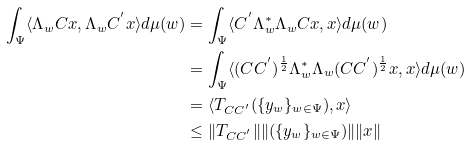<formula> <loc_0><loc_0><loc_500><loc_500>\int _ { \Psi } \langle \Lambda _ { w } C x , \Lambda _ { w } C ^ { ^ { \prime } } x \rangle d \mu ( w ) & = \int _ { \Psi } \langle C ^ { ^ { \prime } } \Lambda ^ { \ast } _ { w } \Lambda _ { w } C x , x \rangle d \mu ( w ) \\ & = \int _ { \Psi } \langle ( C C ^ { ^ { \prime } } ) ^ { \frac { 1 } { 2 } } \Lambda ^ { \ast } _ { w } \Lambda _ { w } ( C C ^ { ^ { \prime } } ) ^ { \frac { 1 } { 2 } } x , x \rangle d \mu ( w ) \\ & = \langle T _ { C C ^ { ^ { \prime } } } ( \{ y _ { w } \} _ { w \in \Psi } ) , x \rangle \\ & \leq \| T _ { C C ^ { ^ { \prime } } } \| \| ( \{ y _ { w } \} _ { w \in \Psi } ) \| \| x \|</formula> 